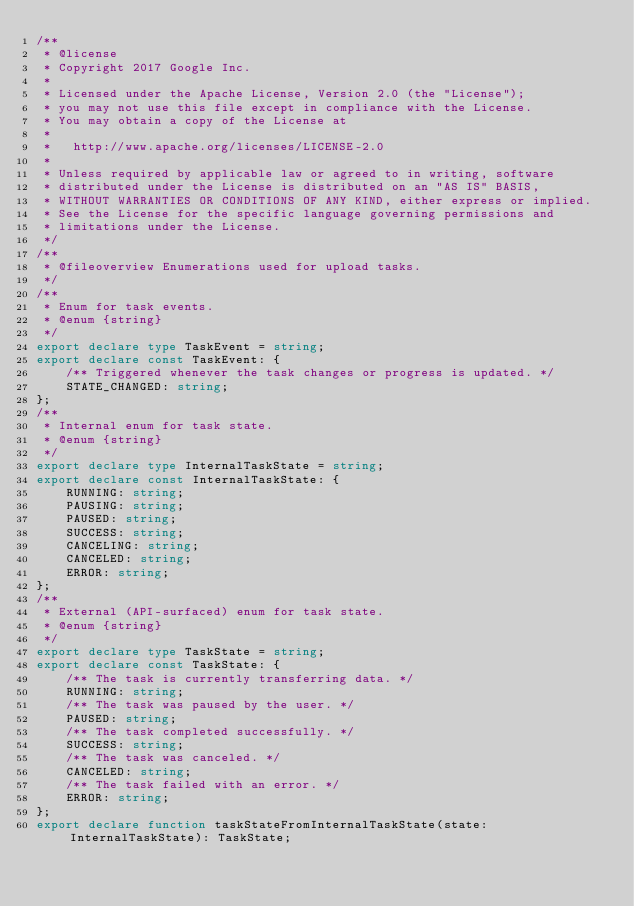<code> <loc_0><loc_0><loc_500><loc_500><_TypeScript_>/**
 * @license
 * Copyright 2017 Google Inc.
 *
 * Licensed under the Apache License, Version 2.0 (the "License");
 * you may not use this file except in compliance with the License.
 * You may obtain a copy of the License at
 *
 *   http://www.apache.org/licenses/LICENSE-2.0
 *
 * Unless required by applicable law or agreed to in writing, software
 * distributed under the License is distributed on an "AS IS" BASIS,
 * WITHOUT WARRANTIES OR CONDITIONS OF ANY KIND, either express or implied.
 * See the License for the specific language governing permissions and
 * limitations under the License.
 */
/**
 * @fileoverview Enumerations used for upload tasks.
 */
/**
 * Enum for task events.
 * @enum {string}
 */
export declare type TaskEvent = string;
export declare const TaskEvent: {
    /** Triggered whenever the task changes or progress is updated. */
    STATE_CHANGED: string;
};
/**
 * Internal enum for task state.
 * @enum {string}
 */
export declare type InternalTaskState = string;
export declare const InternalTaskState: {
    RUNNING: string;
    PAUSING: string;
    PAUSED: string;
    SUCCESS: string;
    CANCELING: string;
    CANCELED: string;
    ERROR: string;
};
/**
 * External (API-surfaced) enum for task state.
 * @enum {string}
 */
export declare type TaskState = string;
export declare const TaskState: {
    /** The task is currently transferring data. */
    RUNNING: string;
    /** The task was paused by the user. */
    PAUSED: string;
    /** The task completed successfully. */
    SUCCESS: string;
    /** The task was canceled. */
    CANCELED: string;
    /** The task failed with an error. */
    ERROR: string;
};
export declare function taskStateFromInternalTaskState(state: InternalTaskState): TaskState;
</code> 